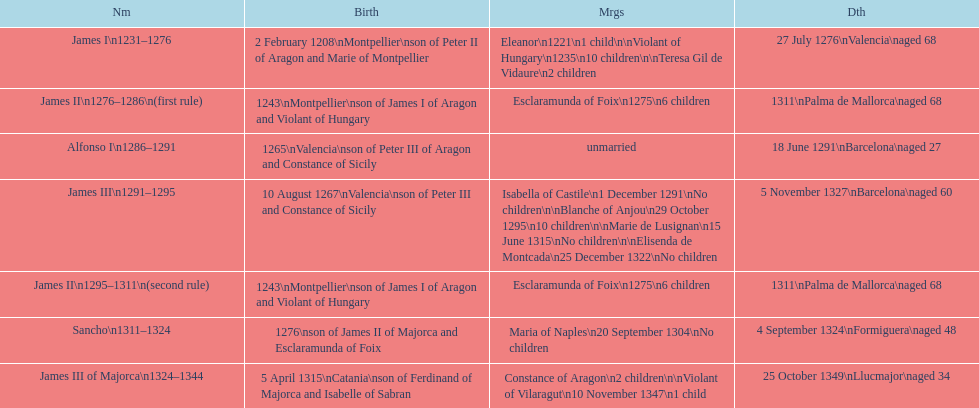What name is above james iii and below james ii? Alfonso I. 